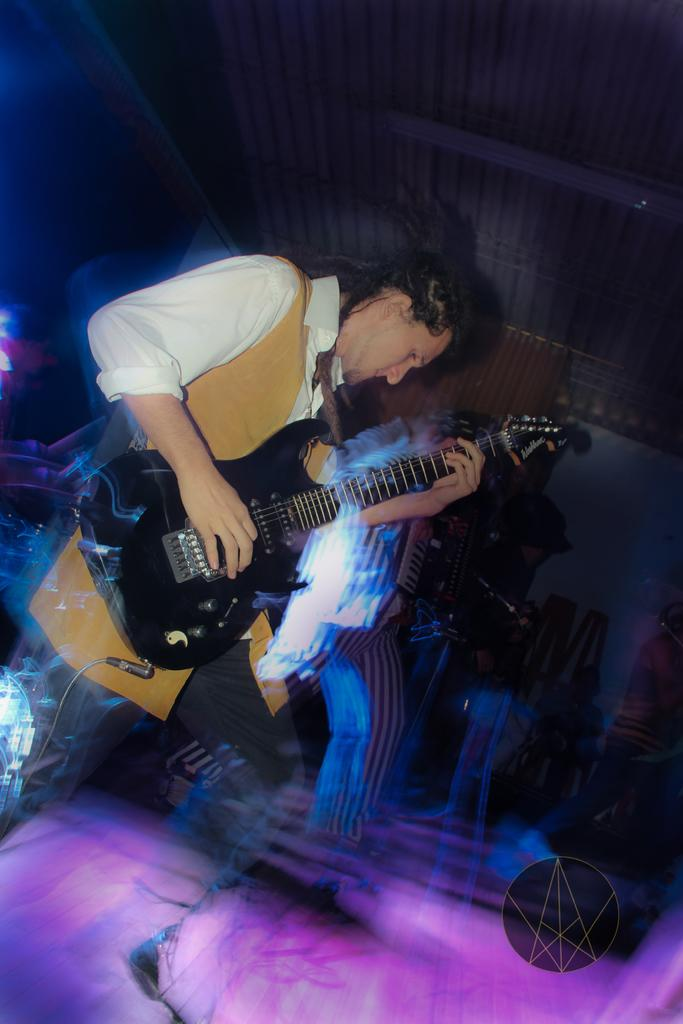What is the man on the floor doing in the image? The man on the floor is playing guitar. Can you describe the lighting situation in the image? There is a light on the floor in the image. What are the other persons in the image doing? The other persons are playing musical instruments. What type of scissors can be seen cutting the guitar strings in the image? There are no scissors present in the image, and the guitar strings are not being cut. 